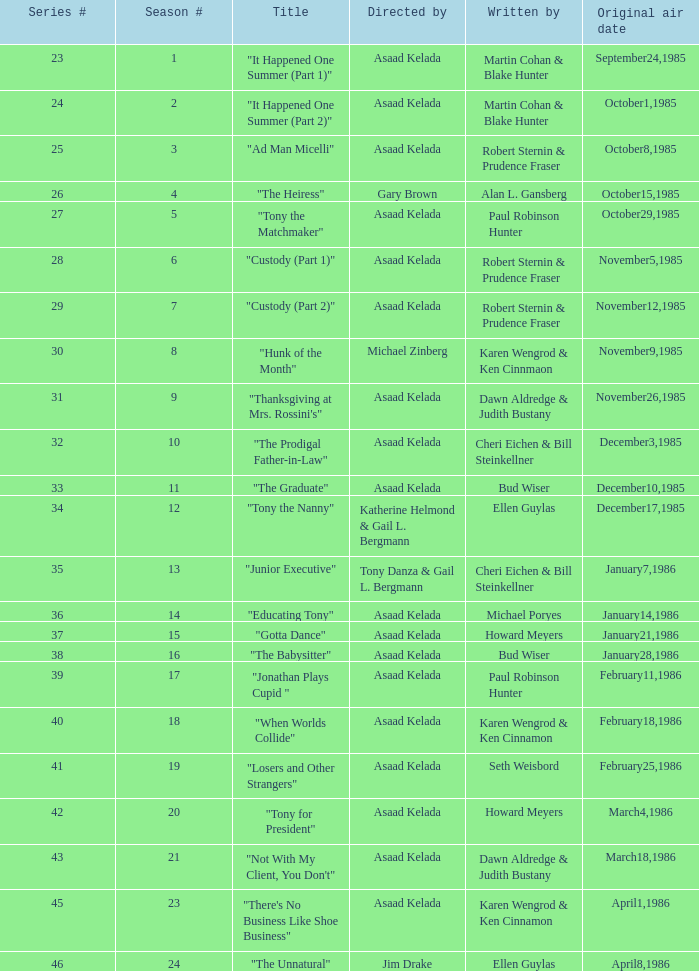What season features writer Michael Poryes? 14.0. 